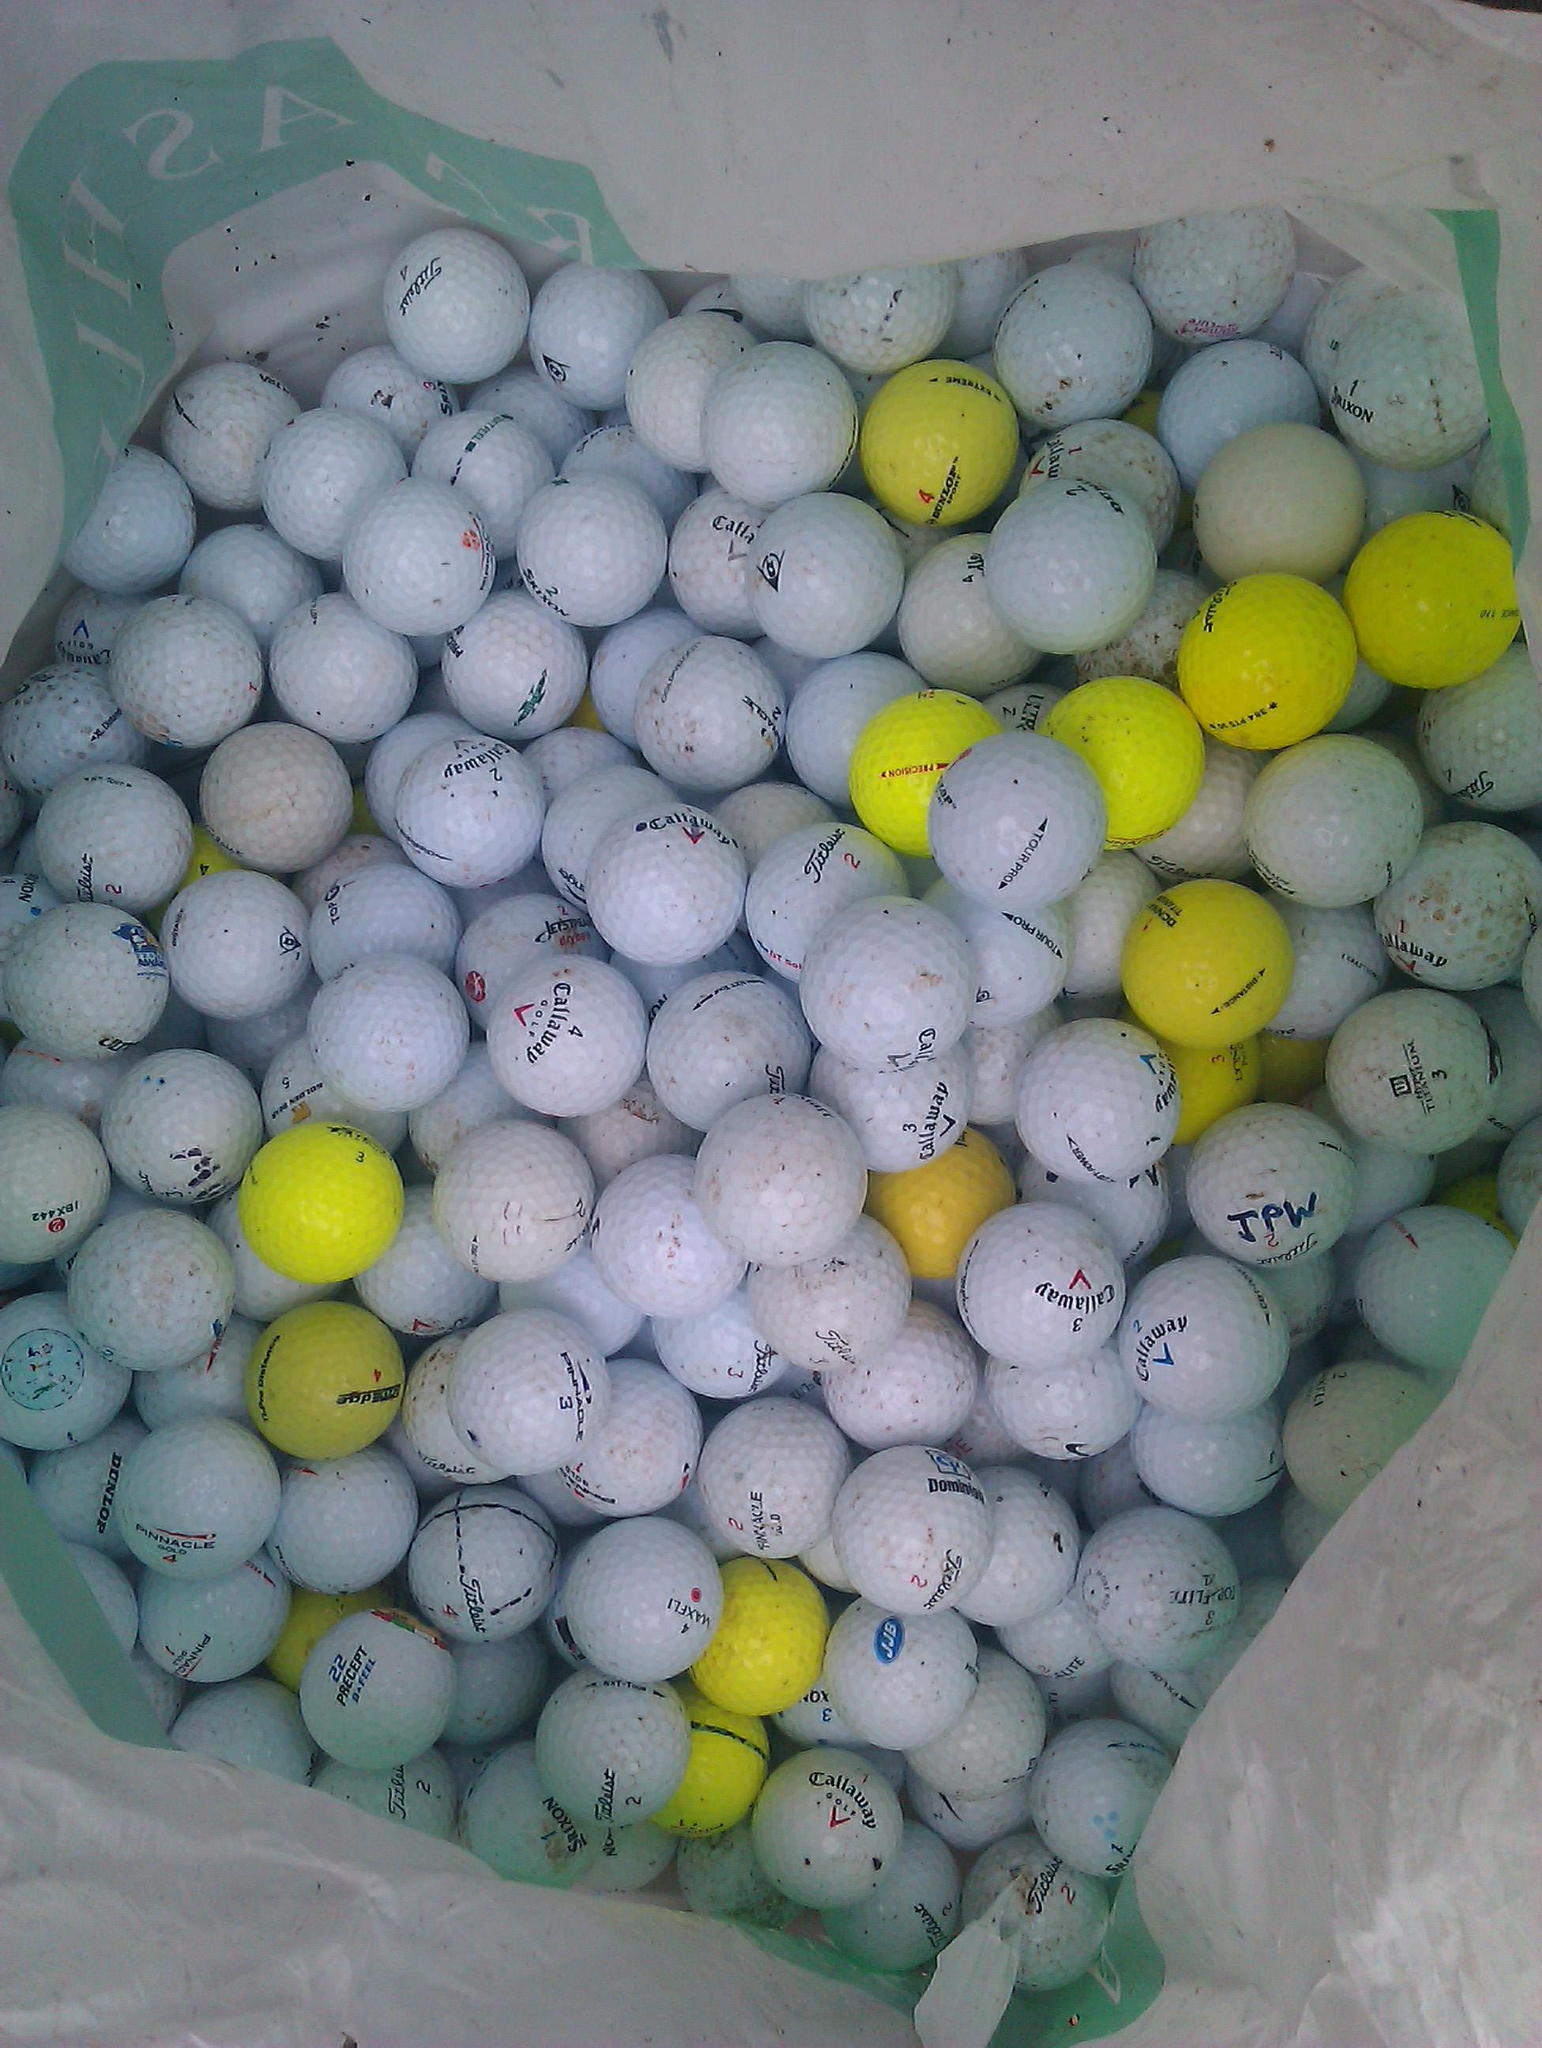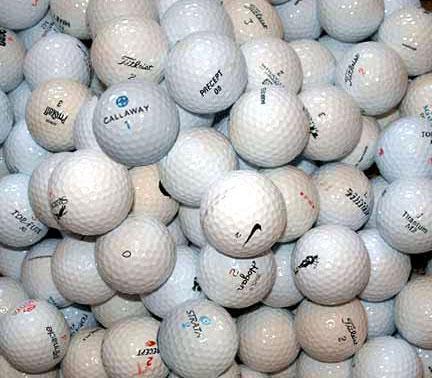The first image is the image on the left, the second image is the image on the right. Considering the images on both sides, is "There is at least one orange golf ball in the image on the left." valid? Answer yes or no. No. 